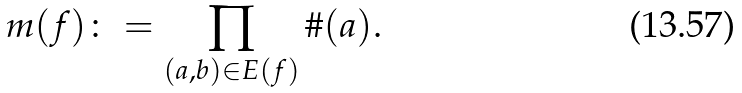<formula> <loc_0><loc_0><loc_500><loc_500>m ( f ) \colon = \prod _ { ( a , b ) \in E ( f ) } \# ( a ) .</formula> 